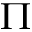<formula> <loc_0><loc_0><loc_500><loc_500>\Pi</formula> 